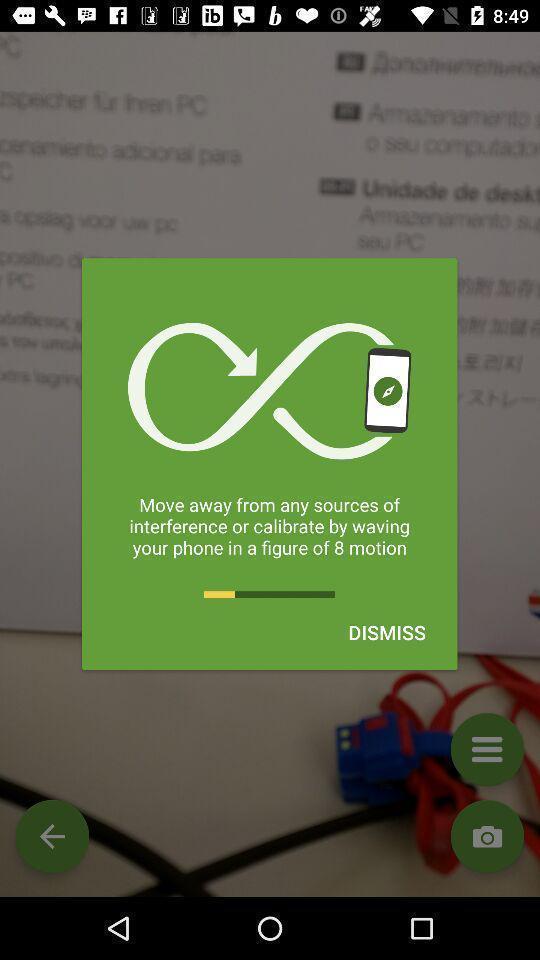What is the overall content of this screenshot? Pop-up showing the way to calibrate a phone. 